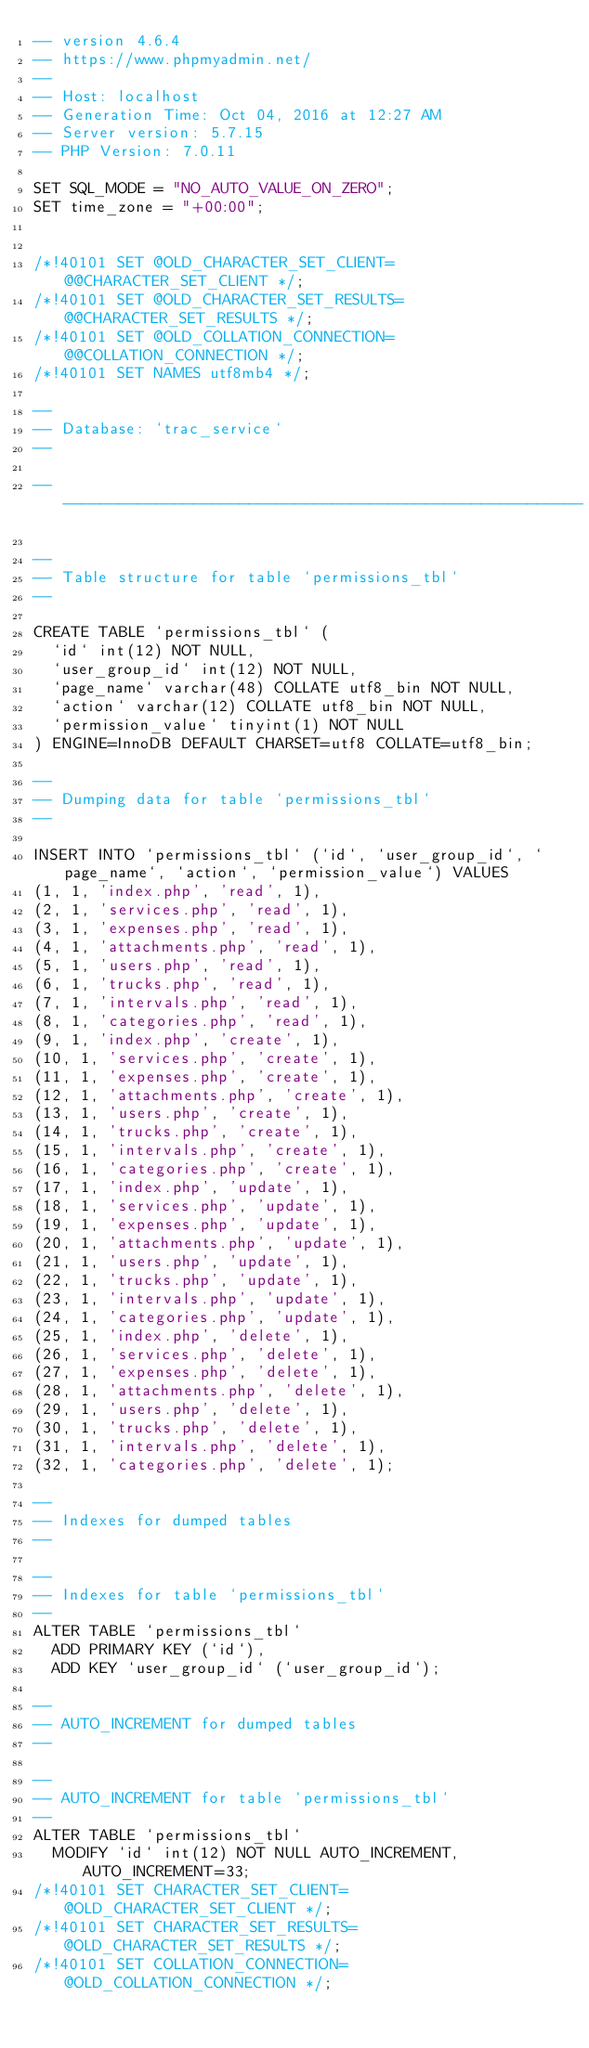<code> <loc_0><loc_0><loc_500><loc_500><_SQL_>-- version 4.6.4
-- https://www.phpmyadmin.net/
--
-- Host: localhost
-- Generation Time: Oct 04, 2016 at 12:27 AM
-- Server version: 5.7.15
-- PHP Version: 7.0.11

SET SQL_MODE = "NO_AUTO_VALUE_ON_ZERO";
SET time_zone = "+00:00";


/*!40101 SET @OLD_CHARACTER_SET_CLIENT=@@CHARACTER_SET_CLIENT */;
/*!40101 SET @OLD_CHARACTER_SET_RESULTS=@@CHARACTER_SET_RESULTS */;
/*!40101 SET @OLD_COLLATION_CONNECTION=@@COLLATION_CONNECTION */;
/*!40101 SET NAMES utf8mb4 */;

--
-- Database: `trac_service`
--

-- --------------------------------------------------------

--
-- Table structure for table `permissions_tbl`
--

CREATE TABLE `permissions_tbl` (
  `id` int(12) NOT NULL,
  `user_group_id` int(12) NOT NULL,
  `page_name` varchar(48) COLLATE utf8_bin NOT NULL,
  `action` varchar(12) COLLATE utf8_bin NOT NULL,
  `permission_value` tinyint(1) NOT NULL
) ENGINE=InnoDB DEFAULT CHARSET=utf8 COLLATE=utf8_bin;

--
-- Dumping data for table `permissions_tbl`
--

INSERT INTO `permissions_tbl` (`id`, `user_group_id`, `page_name`, `action`, `permission_value`) VALUES
(1, 1, 'index.php', 'read', 1),
(2, 1, 'services.php', 'read', 1),
(3, 1, 'expenses.php', 'read', 1),
(4, 1, 'attachments.php', 'read', 1),
(5, 1, 'users.php', 'read', 1),
(6, 1, 'trucks.php', 'read', 1),
(7, 1, 'intervals.php', 'read', 1),
(8, 1, 'categories.php', 'read', 1),
(9, 1, 'index.php', 'create', 1),
(10, 1, 'services.php', 'create', 1),
(11, 1, 'expenses.php', 'create', 1),
(12, 1, 'attachments.php', 'create', 1),
(13, 1, 'users.php', 'create', 1),
(14, 1, 'trucks.php', 'create', 1),
(15, 1, 'intervals.php', 'create', 1),
(16, 1, 'categories.php', 'create', 1),
(17, 1, 'index.php', 'update', 1),
(18, 1, 'services.php', 'update', 1),
(19, 1, 'expenses.php', 'update', 1),
(20, 1, 'attachments.php', 'update', 1),
(21, 1, 'users.php', 'update', 1),
(22, 1, 'trucks.php', 'update', 1),
(23, 1, 'intervals.php', 'update', 1),
(24, 1, 'categories.php', 'update', 1),
(25, 1, 'index.php', 'delete', 1),
(26, 1, 'services.php', 'delete', 1),
(27, 1, 'expenses.php', 'delete', 1),
(28, 1, 'attachments.php', 'delete', 1),
(29, 1, 'users.php', 'delete', 1),
(30, 1, 'trucks.php', 'delete', 1),
(31, 1, 'intervals.php', 'delete', 1),
(32, 1, 'categories.php', 'delete', 1);

--
-- Indexes for dumped tables
--

--
-- Indexes for table `permissions_tbl`
--
ALTER TABLE `permissions_tbl`
  ADD PRIMARY KEY (`id`),
  ADD KEY `user_group_id` (`user_group_id`);

--
-- AUTO_INCREMENT for dumped tables
--

--
-- AUTO_INCREMENT for table `permissions_tbl`
--
ALTER TABLE `permissions_tbl`
  MODIFY `id` int(12) NOT NULL AUTO_INCREMENT, AUTO_INCREMENT=33;
/*!40101 SET CHARACTER_SET_CLIENT=@OLD_CHARACTER_SET_CLIENT */;
/*!40101 SET CHARACTER_SET_RESULTS=@OLD_CHARACTER_SET_RESULTS */;
/*!40101 SET COLLATION_CONNECTION=@OLD_COLLATION_CONNECTION */;
</code> 